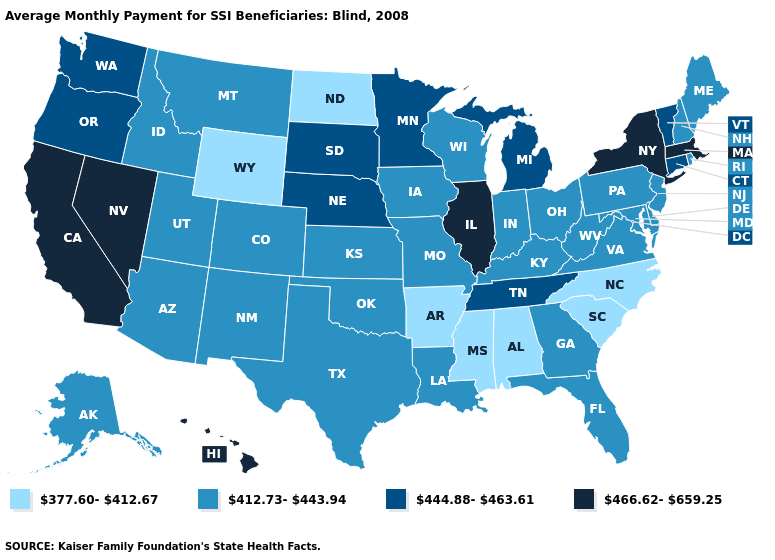Does Louisiana have a higher value than Florida?
Give a very brief answer. No. Among the states that border Wisconsin , which have the lowest value?
Concise answer only. Iowa. Does the first symbol in the legend represent the smallest category?
Be succinct. Yes. What is the value of Kentucky?
Give a very brief answer. 412.73-443.94. What is the value of South Dakota?
Short answer required. 444.88-463.61. What is the lowest value in states that border Washington?
Write a very short answer. 412.73-443.94. What is the highest value in the MidWest ?
Quick response, please. 466.62-659.25. Does Hawaii have the highest value in the USA?
Write a very short answer. Yes. What is the value of New Mexico?
Quick response, please. 412.73-443.94. Which states have the lowest value in the USA?
Concise answer only. Alabama, Arkansas, Mississippi, North Carolina, North Dakota, South Carolina, Wyoming. Does South Dakota have the same value as Florida?
Give a very brief answer. No. Which states have the lowest value in the West?
Concise answer only. Wyoming. Does Florida have the lowest value in the USA?
Be succinct. No. What is the value of Utah?
Short answer required. 412.73-443.94. Name the states that have a value in the range 412.73-443.94?
Write a very short answer. Alaska, Arizona, Colorado, Delaware, Florida, Georgia, Idaho, Indiana, Iowa, Kansas, Kentucky, Louisiana, Maine, Maryland, Missouri, Montana, New Hampshire, New Jersey, New Mexico, Ohio, Oklahoma, Pennsylvania, Rhode Island, Texas, Utah, Virginia, West Virginia, Wisconsin. 